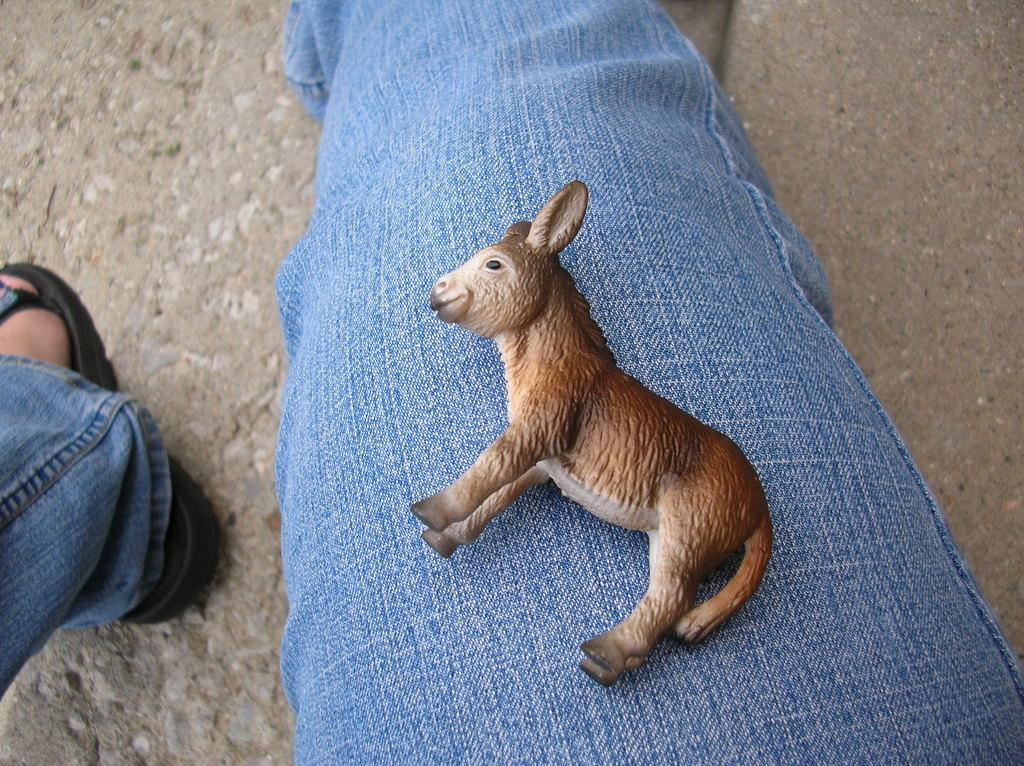What object can be seen in the image? There is a toy in the image. Where is the toy located? The toy is on a person's thigh. What type of clothing is the person wearing? The person is wearing jeans. What type of competition is taking place in the image? There is no competition present in the image; it features a toy on a person's thigh who is wearing jeans. 